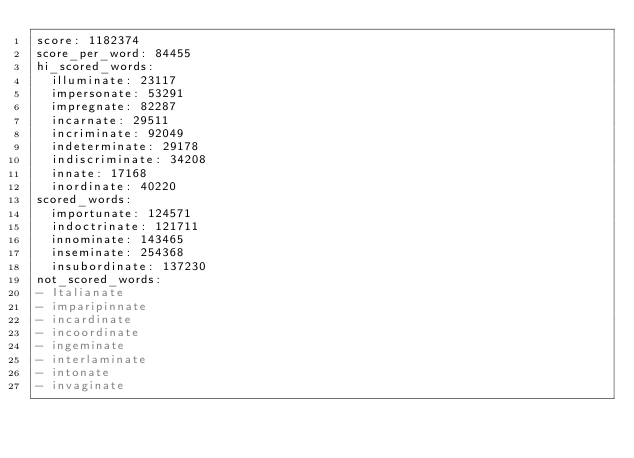Convert code to text. <code><loc_0><loc_0><loc_500><loc_500><_YAML_>score: 1182374
score_per_word: 84455
hi_scored_words:
  illuminate: 23117
  impersonate: 53291
  impregnate: 82287
  incarnate: 29511
  incriminate: 92049
  indeterminate: 29178
  indiscriminate: 34208
  innate: 17168
  inordinate: 40220
scored_words:
  importunate: 124571
  indoctrinate: 121711
  innominate: 143465
  inseminate: 254368
  insubordinate: 137230
not_scored_words:
- Italianate
- imparipinnate
- incardinate
- incoordinate
- ingeminate
- interlaminate
- intonate
- invaginate
</code> 